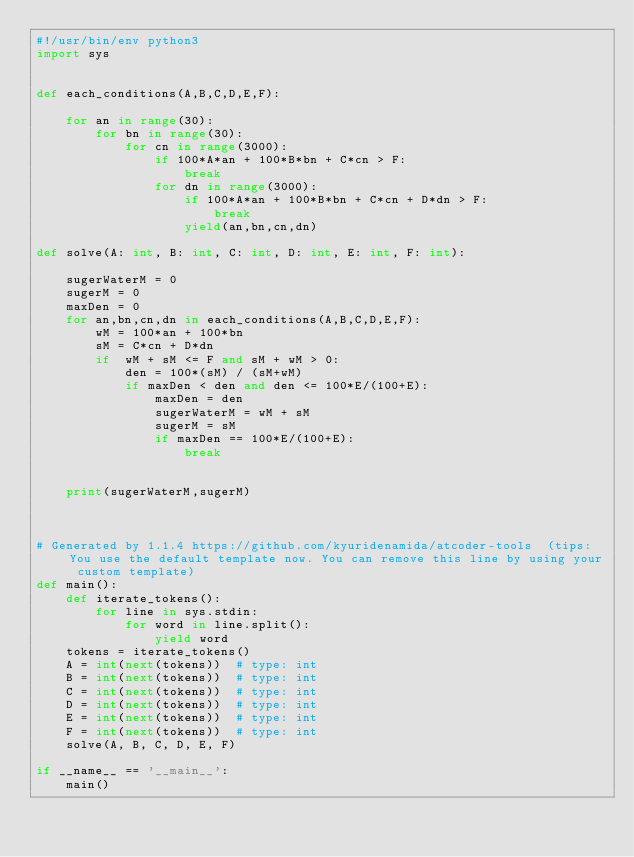Convert code to text. <code><loc_0><loc_0><loc_500><loc_500><_Python_>#!/usr/bin/env python3
import sys


def each_conditions(A,B,C,D,E,F):

    for an in range(30):
        for bn in range(30):
            for cn in range(3000):
                if 100*A*an + 100*B*bn + C*cn > F:
                    break
                for dn in range(3000):
                    if 100*A*an + 100*B*bn + C*cn + D*dn > F:
                        break
                    yield(an,bn,cn,dn)

def solve(A: int, B: int, C: int, D: int, E: int, F: int):

    sugerWaterM = 0
    sugerM = 0
    maxDen = 0
    for an,bn,cn,dn in each_conditions(A,B,C,D,E,F):
        wM = 100*an + 100*bn
        sM = C*cn + D*dn
        if  wM + sM <= F and sM + wM > 0:
            den = 100*(sM) / (sM+wM)
            if maxDen < den and den <= 100*E/(100+E):
                maxDen = den
                sugerWaterM = wM + sM
                sugerM = sM
                if maxDen == 100*E/(100+E):
                    break


    print(sugerWaterM,sugerM)



# Generated by 1.1.4 https://github.com/kyuridenamida/atcoder-tools  (tips: You use the default template now. You can remove this line by using your custom template)
def main():
    def iterate_tokens():
        for line in sys.stdin:
            for word in line.split():
                yield word
    tokens = iterate_tokens()
    A = int(next(tokens))  # type: int
    B = int(next(tokens))  # type: int
    C = int(next(tokens))  # type: int
    D = int(next(tokens))  # type: int
    E = int(next(tokens))  # type: int
    F = int(next(tokens))  # type: int
    solve(A, B, C, D, E, F)

if __name__ == '__main__':
    main()
</code> 